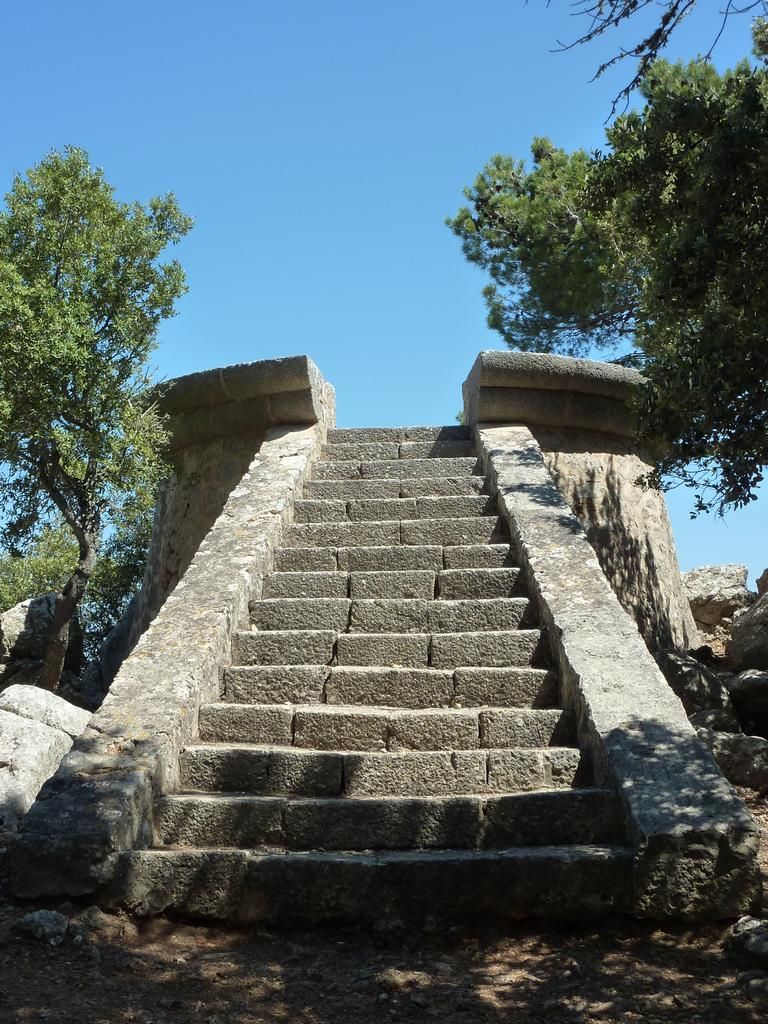What type of structure can be seen in the image? There are stairs in the image. What natural elements are present in the image? There are trees and rocks in the image. What part of the natural environment is visible in the image? The sky is visible in the image. What type of bubble can be seen floating near the trees in the image? There is no bubble present in the image; it only features stairs, trees, rocks, and the sky. 